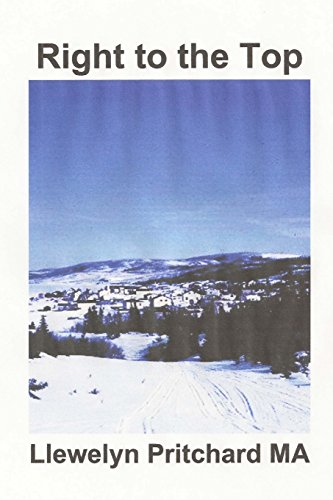Based on the title, what type of intrigue or mystery could be explored in this book? Given the title 'Right to the Top', the book might explore a journey or a challenge to overcome significant obstacles within a corrupt organization, filled with tension and strategic maneuvering. 